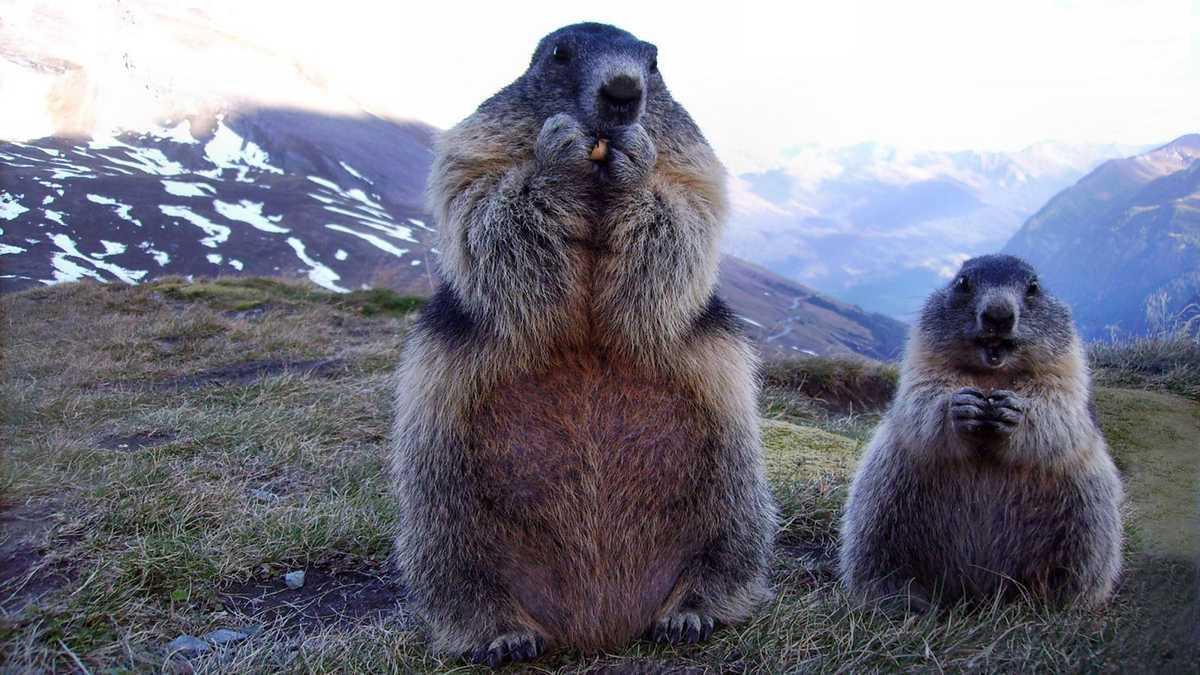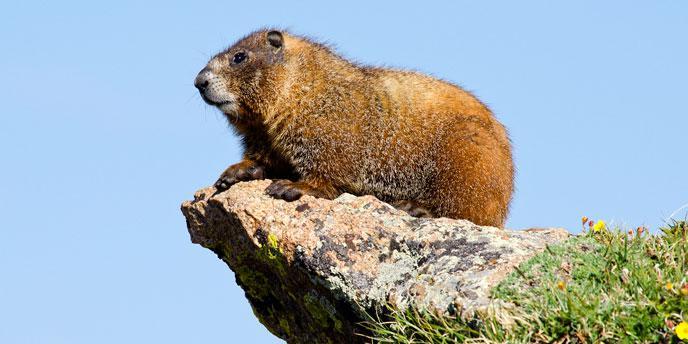The first image is the image on the left, the second image is the image on the right. Examine the images to the left and right. Is the description "The animal in the image on the right is holding orange food." accurate? Answer yes or no. No. 